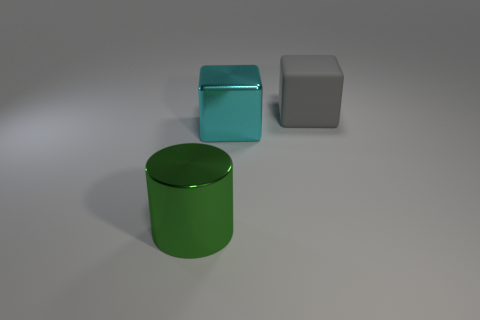Are there more green cylinders behind the metal block than tiny gray rubber cylinders?
Your answer should be compact. No. Are there any big cubes that have the same color as the big shiny cylinder?
Make the answer very short. No. What is the size of the shiny cylinder?
Provide a succinct answer. Large. Is the color of the big metallic cylinder the same as the big rubber thing?
Make the answer very short. No. How many objects are either green things or cyan things left of the gray rubber cube?
Your answer should be compact. 2. There is a large thing that is to the left of the large block that is in front of the big rubber object; how many big green metal objects are left of it?
Offer a very short reply. 0. How many tiny brown metal spheres are there?
Keep it short and to the point. 0. There is a metallic thing that is in front of the cyan shiny thing; does it have the same size as the metallic block?
Provide a short and direct response. Yes. What number of metal things are tiny brown blocks or big green cylinders?
Ensure brevity in your answer.  1. There is a large shiny object behind the green shiny cylinder; how many shiny objects are left of it?
Make the answer very short. 1. 